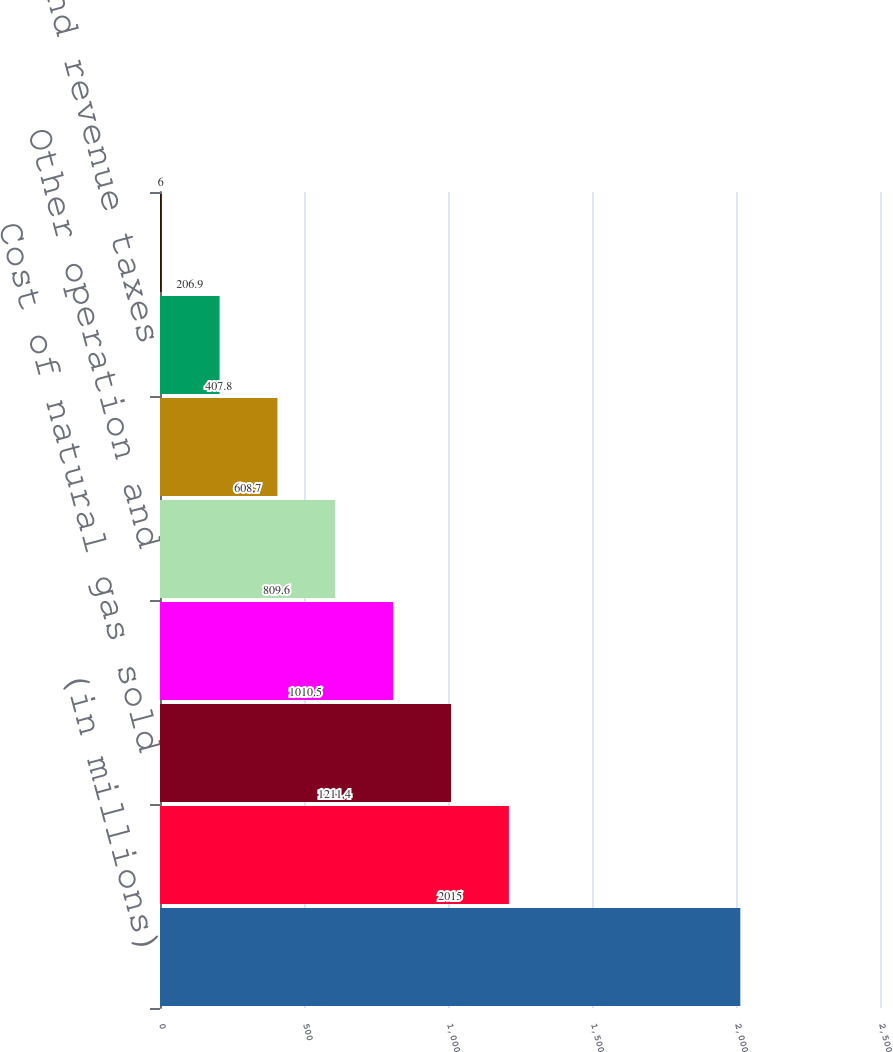<chart> <loc_0><loc_0><loc_500><loc_500><bar_chart><fcel>(in millions)<fcel>Natural gas revenues<fcel>Cost of natural gas sold<fcel>Total natural gas margins<fcel>Other operation and<fcel>Depreciation and amortization<fcel>Property and revenue taxes<fcel>Operating income<nl><fcel>2015<fcel>1211.4<fcel>1010.5<fcel>809.6<fcel>608.7<fcel>407.8<fcel>206.9<fcel>6<nl></chart> 